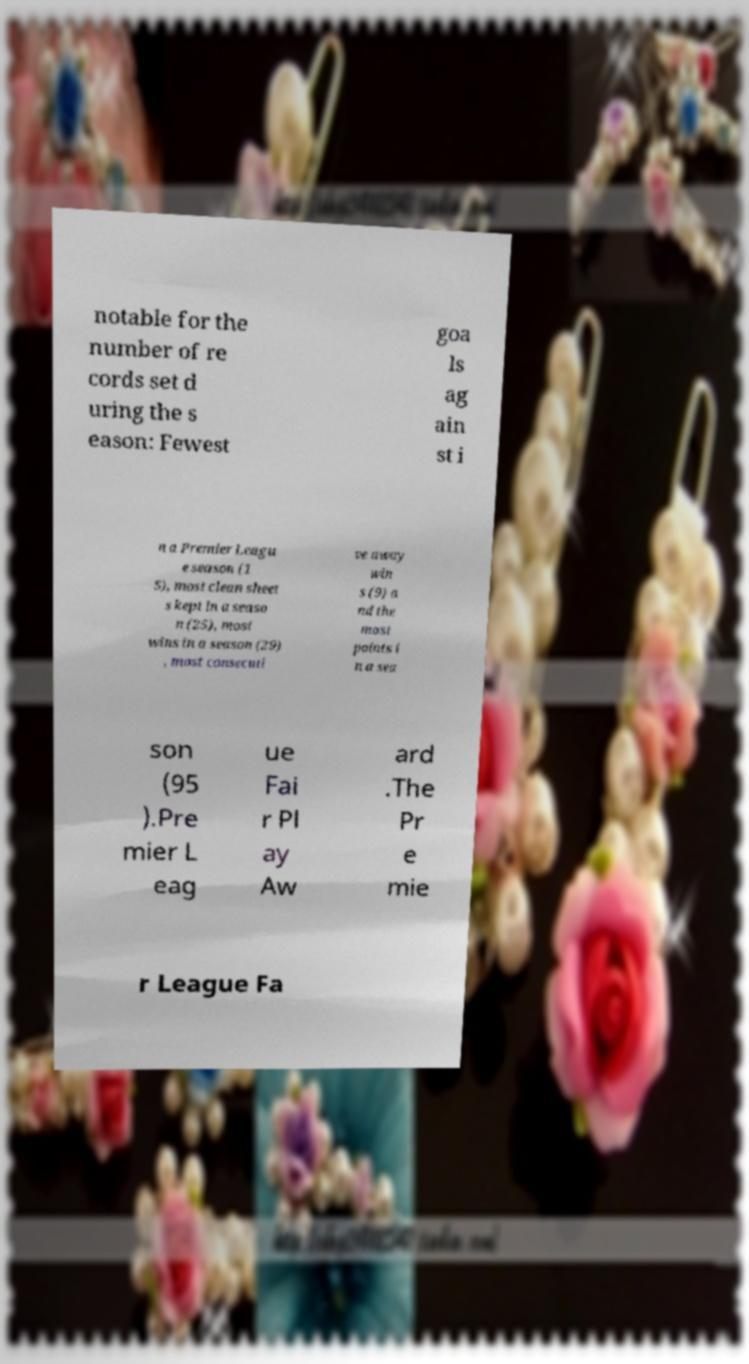For documentation purposes, I need the text within this image transcribed. Could you provide that? notable for the number of re cords set d uring the s eason: Fewest goa ls ag ain st i n a Premier Leagu e season (1 5), most clean sheet s kept in a seaso n (25), most wins in a season (29) , most consecuti ve away win s (9) a nd the most points i n a sea son (95 ).Pre mier L eag ue Fai r Pl ay Aw ard .The Pr e mie r League Fa 